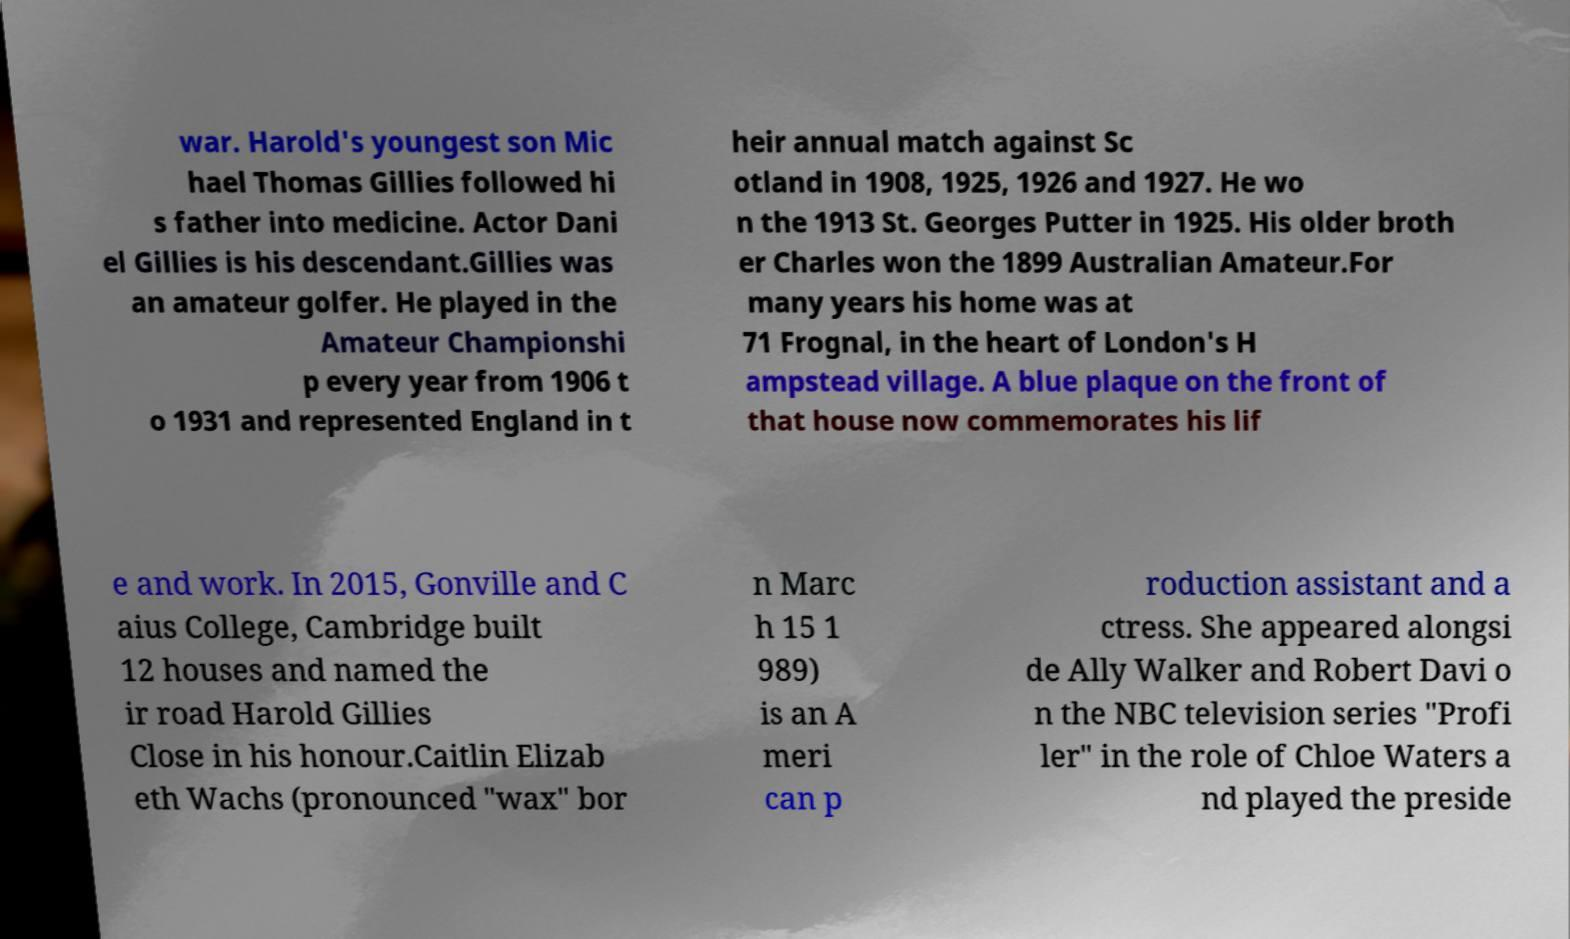Can you read and provide the text displayed in the image?This photo seems to have some interesting text. Can you extract and type it out for me? war. Harold's youngest son Mic hael Thomas Gillies followed hi s father into medicine. Actor Dani el Gillies is his descendant.Gillies was an amateur golfer. He played in the Amateur Championshi p every year from 1906 t o 1931 and represented England in t heir annual match against Sc otland in 1908, 1925, 1926 and 1927. He wo n the 1913 St. Georges Putter in 1925. His older broth er Charles won the 1899 Australian Amateur.For many years his home was at 71 Frognal, in the heart of London's H ampstead village. A blue plaque on the front of that house now commemorates his lif e and work. In 2015, Gonville and C aius College, Cambridge built 12 houses and named the ir road Harold Gillies Close in his honour.Caitlin Elizab eth Wachs (pronounced "wax" bor n Marc h 15 1 989) is an A meri can p roduction assistant and a ctress. She appeared alongsi de Ally Walker and Robert Davi o n the NBC television series "Profi ler" in the role of Chloe Waters a nd played the preside 